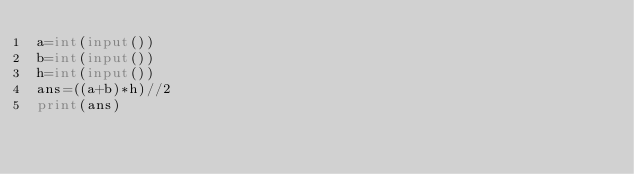Convert code to text. <code><loc_0><loc_0><loc_500><loc_500><_Python_>a=int(input())
b=int(input())
h=int(input())
ans=((a+b)*h)//2
print(ans)</code> 